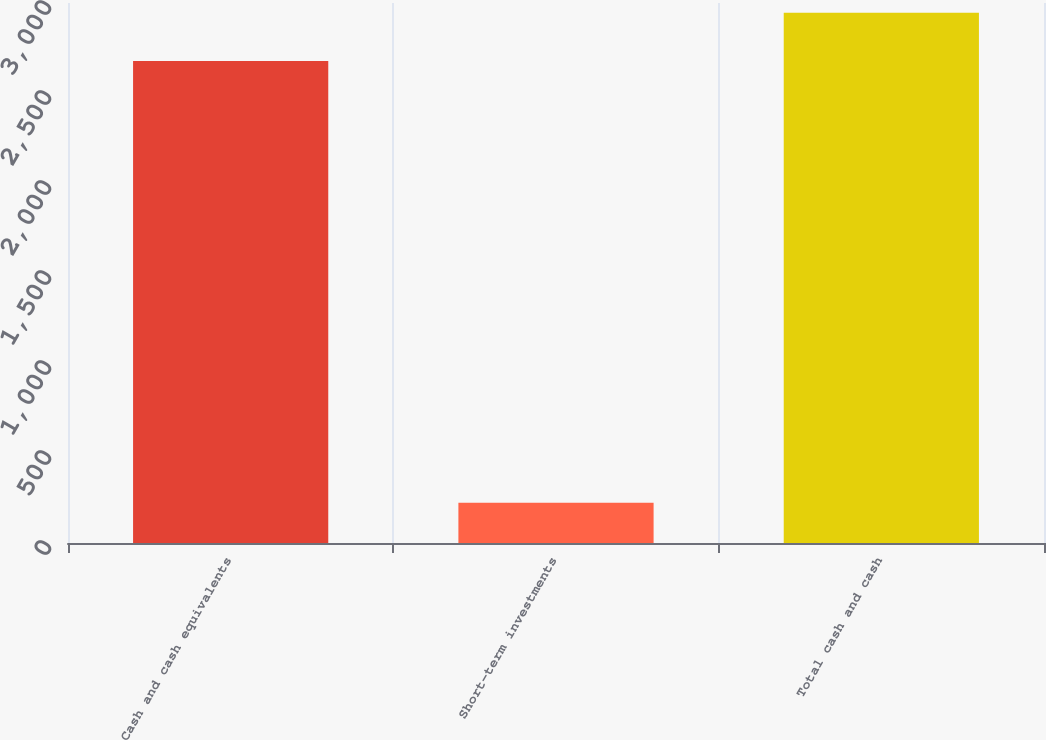Convert chart to OTSL. <chart><loc_0><loc_0><loc_500><loc_500><bar_chart><fcel>Cash and cash equivalents<fcel>Short-term investments<fcel>Total cash and cash<nl><fcel>2678<fcel>223<fcel>2945.8<nl></chart> 